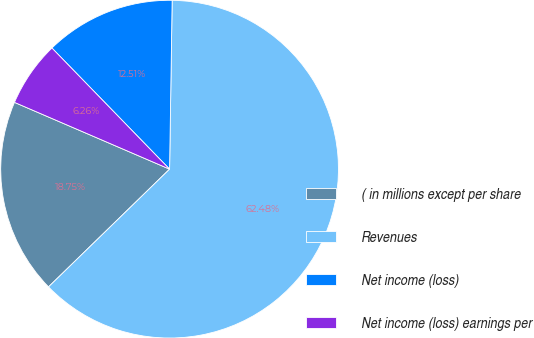<chart> <loc_0><loc_0><loc_500><loc_500><pie_chart><fcel>( in millions except per share<fcel>Revenues<fcel>Net income (loss)<fcel>Net income (loss) earnings per<nl><fcel>18.75%<fcel>62.48%<fcel>12.51%<fcel>6.26%<nl></chart> 